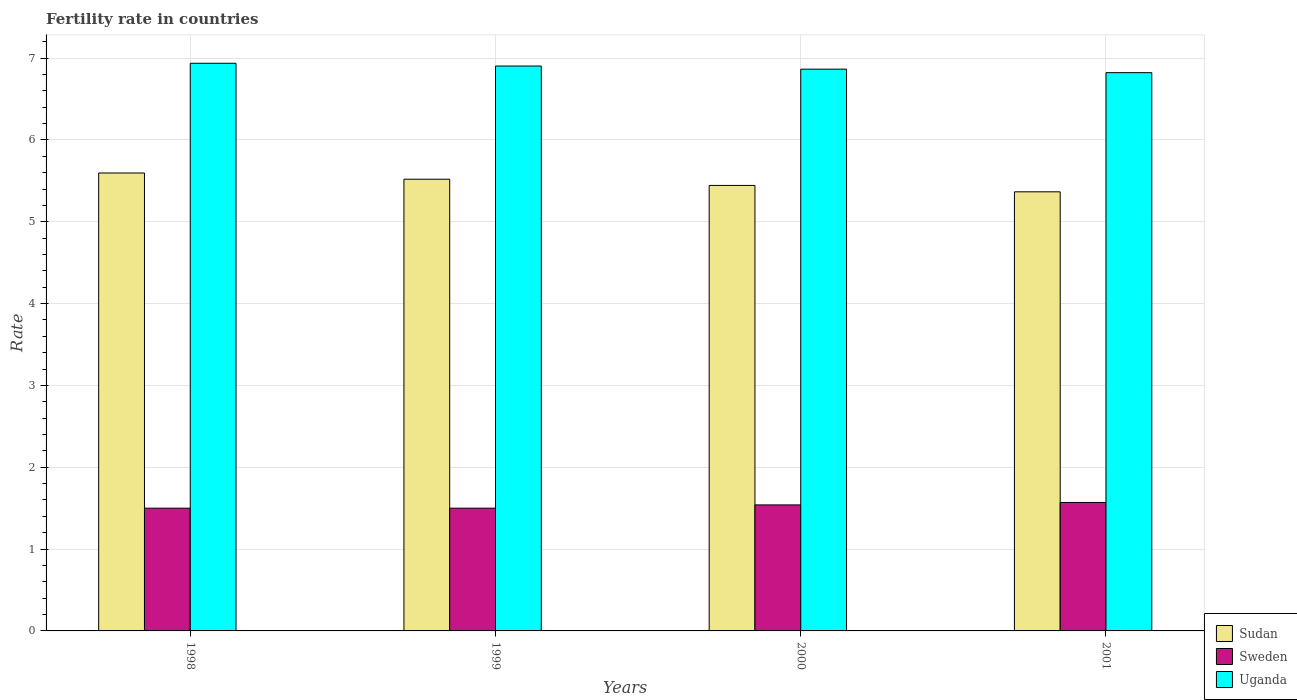How many different coloured bars are there?
Provide a short and direct response. 3. Are the number of bars per tick equal to the number of legend labels?
Your response must be concise. Yes. What is the label of the 3rd group of bars from the left?
Keep it short and to the point. 2000. In how many cases, is the number of bars for a given year not equal to the number of legend labels?
Offer a very short reply. 0. What is the fertility rate in Sweden in 2000?
Your response must be concise. 1.54. Across all years, what is the maximum fertility rate in Sweden?
Your answer should be compact. 1.57. Across all years, what is the minimum fertility rate in Sudan?
Provide a short and direct response. 5.37. In which year was the fertility rate in Uganda maximum?
Provide a succinct answer. 1998. In which year was the fertility rate in Uganda minimum?
Provide a short and direct response. 2001. What is the total fertility rate in Uganda in the graph?
Give a very brief answer. 27.53. What is the difference between the fertility rate in Uganda in 1999 and that in 2001?
Your response must be concise. 0.08. What is the difference between the fertility rate in Sweden in 2000 and the fertility rate in Sudan in 1998?
Offer a very short reply. -4.06. What is the average fertility rate in Sweden per year?
Ensure brevity in your answer.  1.53. In the year 1998, what is the difference between the fertility rate in Sudan and fertility rate in Sweden?
Offer a terse response. 4.1. What is the ratio of the fertility rate in Sudan in 1998 to that in 1999?
Offer a terse response. 1.01. What is the difference between the highest and the second highest fertility rate in Sudan?
Your response must be concise. 0.08. What is the difference between the highest and the lowest fertility rate in Sweden?
Provide a succinct answer. 0.07. Is the sum of the fertility rate in Sudan in 1998 and 2000 greater than the maximum fertility rate in Sweden across all years?
Make the answer very short. Yes. What does the 1st bar from the left in 2001 represents?
Provide a succinct answer. Sudan. What does the 1st bar from the right in 2001 represents?
Offer a very short reply. Uganda. Is it the case that in every year, the sum of the fertility rate in Uganda and fertility rate in Sudan is greater than the fertility rate in Sweden?
Give a very brief answer. Yes. How many years are there in the graph?
Provide a succinct answer. 4. Are the values on the major ticks of Y-axis written in scientific E-notation?
Offer a very short reply. No. Where does the legend appear in the graph?
Give a very brief answer. Bottom right. How many legend labels are there?
Keep it short and to the point. 3. What is the title of the graph?
Provide a succinct answer. Fertility rate in countries. What is the label or title of the Y-axis?
Give a very brief answer. Rate. What is the Rate of Sudan in 1998?
Provide a short and direct response. 5.6. What is the Rate of Uganda in 1998?
Offer a very short reply. 6.94. What is the Rate in Sudan in 1999?
Keep it short and to the point. 5.52. What is the Rate in Uganda in 1999?
Offer a terse response. 6.9. What is the Rate of Sudan in 2000?
Provide a short and direct response. 5.44. What is the Rate in Sweden in 2000?
Keep it short and to the point. 1.54. What is the Rate in Uganda in 2000?
Provide a short and direct response. 6.87. What is the Rate in Sudan in 2001?
Offer a terse response. 5.37. What is the Rate of Sweden in 2001?
Your response must be concise. 1.57. What is the Rate of Uganda in 2001?
Your response must be concise. 6.82. Across all years, what is the maximum Rate in Sudan?
Give a very brief answer. 5.6. Across all years, what is the maximum Rate of Sweden?
Your response must be concise. 1.57. Across all years, what is the maximum Rate in Uganda?
Your answer should be compact. 6.94. Across all years, what is the minimum Rate in Sudan?
Offer a very short reply. 5.37. Across all years, what is the minimum Rate in Sweden?
Keep it short and to the point. 1.5. Across all years, what is the minimum Rate of Uganda?
Your answer should be very brief. 6.82. What is the total Rate of Sudan in the graph?
Keep it short and to the point. 21.93. What is the total Rate of Sweden in the graph?
Ensure brevity in your answer.  6.11. What is the total Rate in Uganda in the graph?
Your answer should be compact. 27.53. What is the difference between the Rate in Sudan in 1998 and that in 1999?
Ensure brevity in your answer.  0.08. What is the difference between the Rate of Sweden in 1998 and that in 1999?
Your answer should be compact. 0. What is the difference between the Rate in Uganda in 1998 and that in 1999?
Offer a very short reply. 0.03. What is the difference between the Rate in Sudan in 1998 and that in 2000?
Offer a terse response. 0.15. What is the difference between the Rate of Sweden in 1998 and that in 2000?
Your response must be concise. -0.04. What is the difference between the Rate of Uganda in 1998 and that in 2000?
Make the answer very short. 0.07. What is the difference between the Rate in Sudan in 1998 and that in 2001?
Your response must be concise. 0.23. What is the difference between the Rate of Sweden in 1998 and that in 2001?
Make the answer very short. -0.07. What is the difference between the Rate of Uganda in 1998 and that in 2001?
Give a very brief answer. 0.12. What is the difference between the Rate of Sudan in 1999 and that in 2000?
Your response must be concise. 0.08. What is the difference between the Rate in Sweden in 1999 and that in 2000?
Your response must be concise. -0.04. What is the difference between the Rate in Uganda in 1999 and that in 2000?
Give a very brief answer. 0.04. What is the difference between the Rate of Sudan in 1999 and that in 2001?
Offer a terse response. 0.15. What is the difference between the Rate of Sweden in 1999 and that in 2001?
Keep it short and to the point. -0.07. What is the difference between the Rate of Uganda in 1999 and that in 2001?
Provide a succinct answer. 0.08. What is the difference between the Rate in Sudan in 2000 and that in 2001?
Ensure brevity in your answer.  0.08. What is the difference between the Rate of Sweden in 2000 and that in 2001?
Make the answer very short. -0.03. What is the difference between the Rate in Uganda in 2000 and that in 2001?
Provide a short and direct response. 0.04. What is the difference between the Rate in Sudan in 1998 and the Rate in Sweden in 1999?
Ensure brevity in your answer.  4.1. What is the difference between the Rate in Sudan in 1998 and the Rate in Uganda in 1999?
Offer a very short reply. -1.31. What is the difference between the Rate of Sweden in 1998 and the Rate of Uganda in 1999?
Offer a terse response. -5.4. What is the difference between the Rate of Sudan in 1998 and the Rate of Sweden in 2000?
Give a very brief answer. 4.06. What is the difference between the Rate of Sudan in 1998 and the Rate of Uganda in 2000?
Your answer should be compact. -1.27. What is the difference between the Rate in Sweden in 1998 and the Rate in Uganda in 2000?
Provide a short and direct response. -5.37. What is the difference between the Rate in Sudan in 1998 and the Rate in Sweden in 2001?
Give a very brief answer. 4.03. What is the difference between the Rate of Sudan in 1998 and the Rate of Uganda in 2001?
Give a very brief answer. -1.23. What is the difference between the Rate in Sweden in 1998 and the Rate in Uganda in 2001?
Ensure brevity in your answer.  -5.32. What is the difference between the Rate in Sudan in 1999 and the Rate in Sweden in 2000?
Provide a succinct answer. 3.98. What is the difference between the Rate of Sudan in 1999 and the Rate of Uganda in 2000?
Keep it short and to the point. -1.34. What is the difference between the Rate of Sweden in 1999 and the Rate of Uganda in 2000?
Ensure brevity in your answer.  -5.37. What is the difference between the Rate of Sudan in 1999 and the Rate of Sweden in 2001?
Your answer should be compact. 3.95. What is the difference between the Rate in Sudan in 1999 and the Rate in Uganda in 2001?
Your answer should be very brief. -1.3. What is the difference between the Rate of Sweden in 1999 and the Rate of Uganda in 2001?
Provide a succinct answer. -5.32. What is the difference between the Rate in Sudan in 2000 and the Rate in Sweden in 2001?
Ensure brevity in your answer.  3.87. What is the difference between the Rate of Sudan in 2000 and the Rate of Uganda in 2001?
Ensure brevity in your answer.  -1.38. What is the difference between the Rate in Sweden in 2000 and the Rate in Uganda in 2001?
Give a very brief answer. -5.28. What is the average Rate in Sudan per year?
Make the answer very short. 5.48. What is the average Rate of Sweden per year?
Your answer should be compact. 1.53. What is the average Rate in Uganda per year?
Your response must be concise. 6.88. In the year 1998, what is the difference between the Rate of Sudan and Rate of Sweden?
Provide a succinct answer. 4.1. In the year 1998, what is the difference between the Rate of Sudan and Rate of Uganda?
Provide a succinct answer. -1.34. In the year 1998, what is the difference between the Rate of Sweden and Rate of Uganda?
Make the answer very short. -5.44. In the year 1999, what is the difference between the Rate of Sudan and Rate of Sweden?
Provide a short and direct response. 4.02. In the year 1999, what is the difference between the Rate of Sudan and Rate of Uganda?
Offer a terse response. -1.38. In the year 1999, what is the difference between the Rate in Sweden and Rate in Uganda?
Provide a short and direct response. -5.4. In the year 2000, what is the difference between the Rate of Sudan and Rate of Sweden?
Provide a short and direct response. 3.9. In the year 2000, what is the difference between the Rate of Sudan and Rate of Uganda?
Your answer should be very brief. -1.42. In the year 2000, what is the difference between the Rate in Sweden and Rate in Uganda?
Your response must be concise. -5.33. In the year 2001, what is the difference between the Rate in Sudan and Rate in Sweden?
Provide a short and direct response. 3.8. In the year 2001, what is the difference between the Rate of Sudan and Rate of Uganda?
Your answer should be very brief. -1.46. In the year 2001, what is the difference between the Rate of Sweden and Rate of Uganda?
Give a very brief answer. -5.25. What is the ratio of the Rate in Sudan in 1998 to that in 1999?
Give a very brief answer. 1.01. What is the ratio of the Rate of Sudan in 1998 to that in 2000?
Provide a succinct answer. 1.03. What is the ratio of the Rate in Sweden in 1998 to that in 2000?
Your answer should be compact. 0.97. What is the ratio of the Rate of Uganda in 1998 to that in 2000?
Your answer should be compact. 1.01. What is the ratio of the Rate in Sudan in 1998 to that in 2001?
Offer a terse response. 1.04. What is the ratio of the Rate in Sweden in 1998 to that in 2001?
Keep it short and to the point. 0.96. What is the ratio of the Rate in Uganda in 1998 to that in 2001?
Keep it short and to the point. 1.02. What is the ratio of the Rate in Uganda in 1999 to that in 2000?
Provide a succinct answer. 1.01. What is the ratio of the Rate of Sudan in 1999 to that in 2001?
Offer a terse response. 1.03. What is the ratio of the Rate in Sweden in 1999 to that in 2001?
Offer a terse response. 0.96. What is the ratio of the Rate of Uganda in 1999 to that in 2001?
Offer a terse response. 1.01. What is the ratio of the Rate in Sudan in 2000 to that in 2001?
Make the answer very short. 1.01. What is the ratio of the Rate of Sweden in 2000 to that in 2001?
Provide a succinct answer. 0.98. What is the ratio of the Rate in Uganda in 2000 to that in 2001?
Your answer should be compact. 1.01. What is the difference between the highest and the second highest Rate in Sudan?
Keep it short and to the point. 0.08. What is the difference between the highest and the second highest Rate of Uganda?
Your answer should be compact. 0.03. What is the difference between the highest and the lowest Rate of Sudan?
Your answer should be compact. 0.23. What is the difference between the highest and the lowest Rate in Sweden?
Give a very brief answer. 0.07. What is the difference between the highest and the lowest Rate of Uganda?
Give a very brief answer. 0.12. 